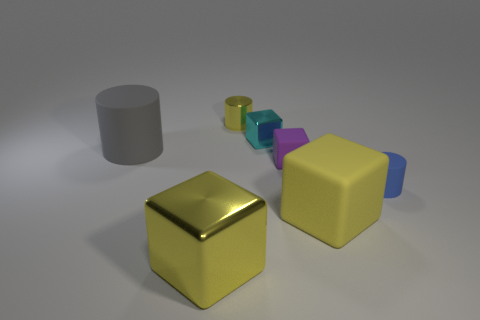Subtract all tiny shiny cylinders. How many cylinders are left? 2 Subtract all gray cylinders. How many cylinders are left? 2 Subtract all cylinders. How many objects are left? 4 Add 2 cyan cubes. How many objects exist? 9 Subtract all brown blocks. How many gray cylinders are left? 1 Subtract all big things. Subtract all small yellow shiny objects. How many objects are left? 3 Add 5 blue objects. How many blue objects are left? 6 Add 1 gray rubber blocks. How many gray rubber blocks exist? 1 Subtract 0 red cylinders. How many objects are left? 7 Subtract 1 cubes. How many cubes are left? 3 